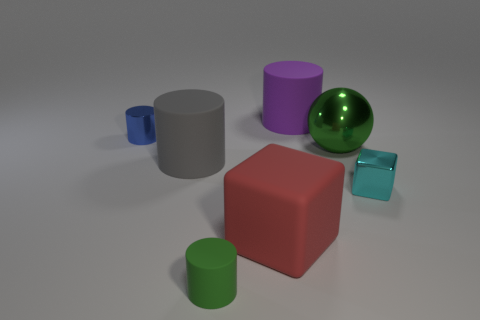Subtract all large purple matte cylinders. How many cylinders are left? 3 Subtract 1 cylinders. How many cylinders are left? 3 Subtract all blue cylinders. How many cylinders are left? 3 Add 2 green shiny objects. How many green shiny objects exist? 3 Add 1 large red things. How many objects exist? 8 Subtract 0 cyan balls. How many objects are left? 7 Subtract all spheres. How many objects are left? 6 Subtract all cyan blocks. Subtract all blue cylinders. How many blocks are left? 1 Subtract all cyan cylinders. How many cyan blocks are left? 1 Subtract all blue things. Subtract all metallic spheres. How many objects are left? 5 